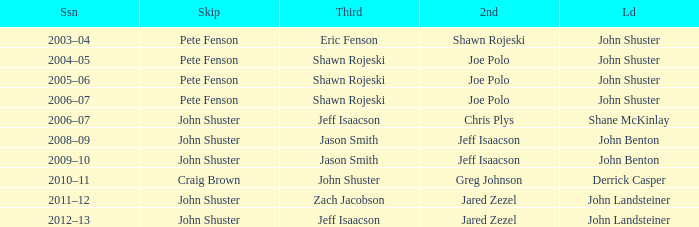Who was the lead with John Shuster as skip, Chris Plys in second, and Jeff Isaacson in third? Shane McKinlay. 